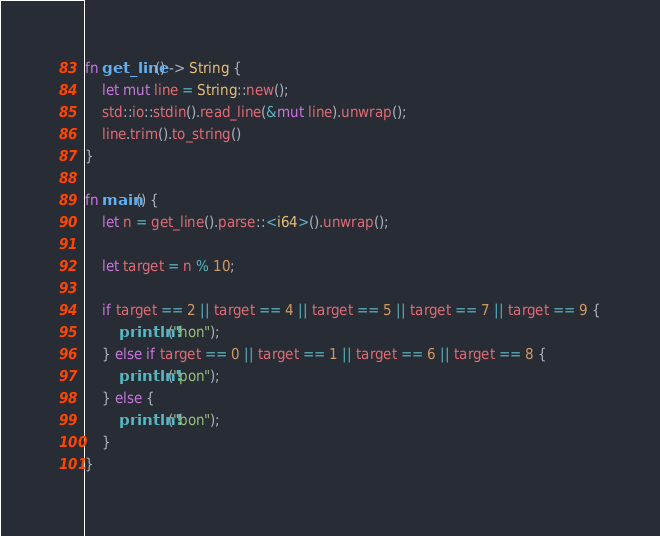<code> <loc_0><loc_0><loc_500><loc_500><_Rust_>fn get_line() -> String {
    let mut line = String::new();
    std::io::stdin().read_line(&mut line).unwrap();
    line.trim().to_string()
}

fn main() {
    let n = get_line().parse::<i64>().unwrap();

    let target = n % 10;

    if target == 2 || target == 4 || target == 5 || target == 7 || target == 9 {
        println!("hon");
    } else if target == 0 || target == 1 || target == 6 || target == 8 {
        println!("pon");
    } else {
        println!("bon");
    } 
}
</code> 